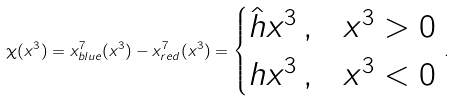Convert formula to latex. <formula><loc_0><loc_0><loc_500><loc_500>\chi ( x ^ { 3 } ) = x ^ { 7 } _ { b l u e } ( x ^ { 3 } ) - x ^ { 7 } _ { r e d } ( x ^ { 3 } ) = \begin{cases} \hat { h } x ^ { 3 } \, , & x ^ { 3 } > 0 \\ h x ^ { 3 } \, , & x ^ { 3 } < 0 \end{cases} \, .</formula> 